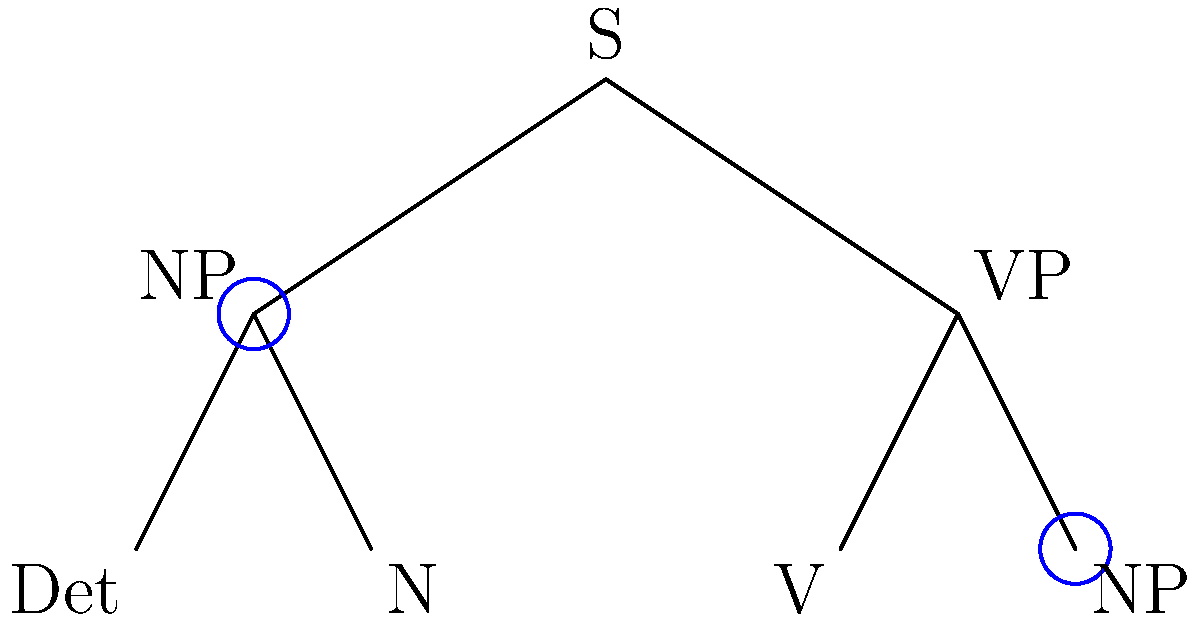In the syntactic tree diagram above, which two elements are highlighted as congruent, and what does this congruence signify in terms of linguistic structure? To answer this question, let's analyze the syntactic tree diagram step-by-step:

1. The diagram represents a basic sentence structure with a root node "S" (Sentence) branching into "NP" (Noun Phrase) and "VP" (Verb Phrase).

2. Two elements are highlighted with blue circles: the left "NP" under "S" and the right "NP" under "VP".

3. In syntactic theory, congruent elements in a tree diagram typically represent phrases or constituents that have the same syntactic category and function.

4. The congruence of these two "NP" nodes signifies that they are both noun phrases, despite occurring in different positions within the sentence structure.

5. The left "NP" is likely the subject of the sentence, while the right "NP" is probably the object of the verb in the "VP".

6. This congruence demonstrates that noun phrases can occupy different syntactic positions (subject, object) while maintaining the same basic internal structure.

7. In linguistic analysis, recognizing such congruences is crucial for understanding how different parts of a sentence relate to each other and how they contribute to the overall meaning and structure of the sentence.
Answer: NP (Noun Phrase); same syntactic category in different positions 